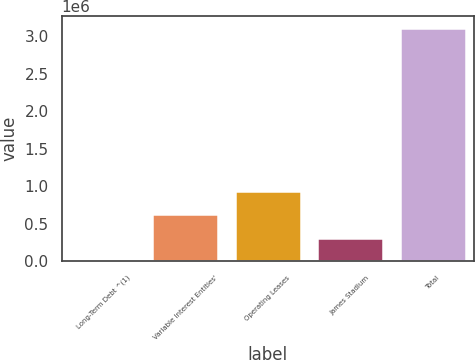<chart> <loc_0><loc_0><loc_500><loc_500><bar_chart><fcel>Long-Term Debt ^(1)<fcel>Variable Interest Entities'<fcel>Operating Leases<fcel>James Stadium<fcel>Total<nl><fcel>3075<fcel>625616<fcel>936886<fcel>314345<fcel>3.11578e+06<nl></chart> 